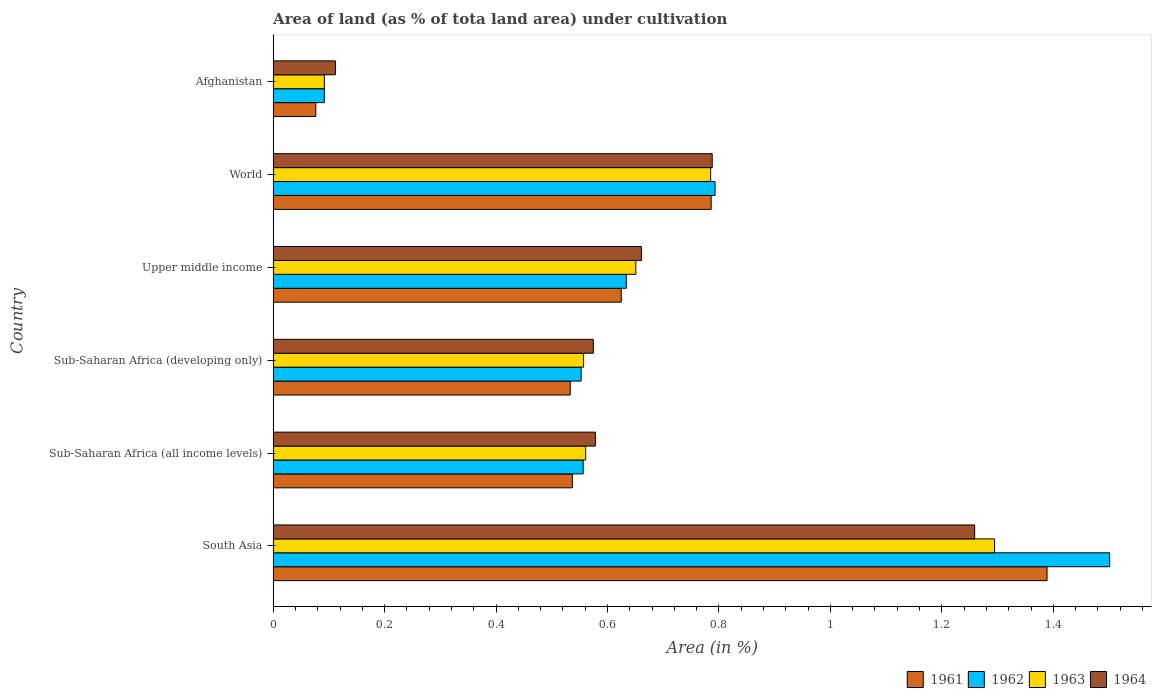How many different coloured bars are there?
Ensure brevity in your answer.  4. How many groups of bars are there?
Offer a terse response. 6. Are the number of bars per tick equal to the number of legend labels?
Your answer should be compact. Yes. Are the number of bars on each tick of the Y-axis equal?
Ensure brevity in your answer.  Yes. What is the label of the 5th group of bars from the top?
Make the answer very short. Sub-Saharan Africa (all income levels). What is the percentage of land under cultivation in 1964 in South Asia?
Provide a succinct answer. 1.26. Across all countries, what is the maximum percentage of land under cultivation in 1962?
Your answer should be very brief. 1.5. Across all countries, what is the minimum percentage of land under cultivation in 1962?
Give a very brief answer. 0.09. In which country was the percentage of land under cultivation in 1964 maximum?
Provide a short and direct response. South Asia. In which country was the percentage of land under cultivation in 1963 minimum?
Your answer should be very brief. Afghanistan. What is the total percentage of land under cultivation in 1962 in the graph?
Make the answer very short. 4.13. What is the difference between the percentage of land under cultivation in 1962 in Upper middle income and that in World?
Provide a short and direct response. -0.16. What is the difference between the percentage of land under cultivation in 1961 in Sub-Saharan Africa (all income levels) and the percentage of land under cultivation in 1964 in Afghanistan?
Provide a short and direct response. 0.43. What is the average percentage of land under cultivation in 1962 per country?
Offer a very short reply. 0.69. What is the difference between the percentage of land under cultivation in 1963 and percentage of land under cultivation in 1961 in Sub-Saharan Africa (all income levels)?
Offer a very short reply. 0.02. What is the ratio of the percentage of land under cultivation in 1964 in Afghanistan to that in Upper middle income?
Make the answer very short. 0.17. Is the difference between the percentage of land under cultivation in 1963 in Upper middle income and World greater than the difference between the percentage of land under cultivation in 1961 in Upper middle income and World?
Your answer should be very brief. Yes. What is the difference between the highest and the second highest percentage of land under cultivation in 1964?
Ensure brevity in your answer.  0.47. What is the difference between the highest and the lowest percentage of land under cultivation in 1963?
Offer a very short reply. 1.2. Is it the case that in every country, the sum of the percentage of land under cultivation in 1963 and percentage of land under cultivation in 1964 is greater than the sum of percentage of land under cultivation in 1961 and percentage of land under cultivation in 1962?
Provide a short and direct response. No. What does the 4th bar from the top in Upper middle income represents?
Your response must be concise. 1961. What does the 3rd bar from the bottom in Sub-Saharan Africa (all income levels) represents?
Your response must be concise. 1963. Is it the case that in every country, the sum of the percentage of land under cultivation in 1962 and percentage of land under cultivation in 1964 is greater than the percentage of land under cultivation in 1961?
Your answer should be compact. Yes. Are all the bars in the graph horizontal?
Make the answer very short. Yes. Does the graph contain grids?
Provide a short and direct response. No. Where does the legend appear in the graph?
Ensure brevity in your answer.  Bottom right. How are the legend labels stacked?
Give a very brief answer. Horizontal. What is the title of the graph?
Your answer should be very brief. Area of land (as % of tota land area) under cultivation. Does "1991" appear as one of the legend labels in the graph?
Ensure brevity in your answer.  No. What is the label or title of the X-axis?
Your answer should be very brief. Area (in %). What is the Area (in %) in 1961 in South Asia?
Offer a very short reply. 1.39. What is the Area (in %) in 1962 in South Asia?
Your response must be concise. 1.5. What is the Area (in %) of 1963 in South Asia?
Give a very brief answer. 1.29. What is the Area (in %) of 1964 in South Asia?
Offer a terse response. 1.26. What is the Area (in %) of 1961 in Sub-Saharan Africa (all income levels)?
Provide a short and direct response. 0.54. What is the Area (in %) of 1962 in Sub-Saharan Africa (all income levels)?
Give a very brief answer. 0.56. What is the Area (in %) in 1963 in Sub-Saharan Africa (all income levels)?
Offer a terse response. 0.56. What is the Area (in %) in 1964 in Sub-Saharan Africa (all income levels)?
Give a very brief answer. 0.58. What is the Area (in %) in 1961 in Sub-Saharan Africa (developing only)?
Provide a succinct answer. 0.53. What is the Area (in %) of 1962 in Sub-Saharan Africa (developing only)?
Provide a short and direct response. 0.55. What is the Area (in %) of 1963 in Sub-Saharan Africa (developing only)?
Provide a succinct answer. 0.56. What is the Area (in %) in 1964 in Sub-Saharan Africa (developing only)?
Provide a succinct answer. 0.57. What is the Area (in %) of 1961 in Upper middle income?
Give a very brief answer. 0.62. What is the Area (in %) in 1962 in Upper middle income?
Your answer should be compact. 0.63. What is the Area (in %) of 1963 in Upper middle income?
Provide a short and direct response. 0.65. What is the Area (in %) in 1964 in Upper middle income?
Give a very brief answer. 0.66. What is the Area (in %) in 1961 in World?
Provide a succinct answer. 0.79. What is the Area (in %) in 1962 in World?
Your answer should be very brief. 0.79. What is the Area (in %) in 1963 in World?
Offer a terse response. 0.79. What is the Area (in %) in 1964 in World?
Your answer should be very brief. 0.79. What is the Area (in %) of 1961 in Afghanistan?
Give a very brief answer. 0.08. What is the Area (in %) of 1962 in Afghanistan?
Ensure brevity in your answer.  0.09. What is the Area (in %) in 1963 in Afghanistan?
Provide a short and direct response. 0.09. What is the Area (in %) of 1964 in Afghanistan?
Your answer should be compact. 0.11. Across all countries, what is the maximum Area (in %) in 1961?
Your response must be concise. 1.39. Across all countries, what is the maximum Area (in %) in 1962?
Provide a short and direct response. 1.5. Across all countries, what is the maximum Area (in %) of 1963?
Your response must be concise. 1.29. Across all countries, what is the maximum Area (in %) of 1964?
Ensure brevity in your answer.  1.26. Across all countries, what is the minimum Area (in %) in 1961?
Make the answer very short. 0.08. Across all countries, what is the minimum Area (in %) in 1962?
Your answer should be very brief. 0.09. Across all countries, what is the minimum Area (in %) of 1963?
Make the answer very short. 0.09. Across all countries, what is the minimum Area (in %) in 1964?
Keep it short and to the point. 0.11. What is the total Area (in %) of 1961 in the graph?
Provide a succinct answer. 3.95. What is the total Area (in %) of 1962 in the graph?
Provide a short and direct response. 4.13. What is the total Area (in %) of 1963 in the graph?
Provide a short and direct response. 3.94. What is the total Area (in %) of 1964 in the graph?
Provide a short and direct response. 3.97. What is the difference between the Area (in %) of 1961 in South Asia and that in Sub-Saharan Africa (all income levels)?
Make the answer very short. 0.85. What is the difference between the Area (in %) of 1962 in South Asia and that in Sub-Saharan Africa (all income levels)?
Offer a terse response. 0.94. What is the difference between the Area (in %) of 1963 in South Asia and that in Sub-Saharan Africa (all income levels)?
Provide a short and direct response. 0.73. What is the difference between the Area (in %) of 1964 in South Asia and that in Sub-Saharan Africa (all income levels)?
Provide a short and direct response. 0.68. What is the difference between the Area (in %) of 1961 in South Asia and that in Sub-Saharan Africa (developing only)?
Your answer should be compact. 0.86. What is the difference between the Area (in %) of 1962 in South Asia and that in Sub-Saharan Africa (developing only)?
Make the answer very short. 0.95. What is the difference between the Area (in %) of 1963 in South Asia and that in Sub-Saharan Africa (developing only)?
Give a very brief answer. 0.74. What is the difference between the Area (in %) in 1964 in South Asia and that in Sub-Saharan Africa (developing only)?
Your response must be concise. 0.68. What is the difference between the Area (in %) in 1961 in South Asia and that in Upper middle income?
Your answer should be very brief. 0.76. What is the difference between the Area (in %) in 1962 in South Asia and that in Upper middle income?
Your answer should be compact. 0.87. What is the difference between the Area (in %) in 1963 in South Asia and that in Upper middle income?
Offer a very short reply. 0.64. What is the difference between the Area (in %) of 1964 in South Asia and that in Upper middle income?
Offer a terse response. 0.6. What is the difference between the Area (in %) in 1961 in South Asia and that in World?
Provide a short and direct response. 0.6. What is the difference between the Area (in %) of 1962 in South Asia and that in World?
Your answer should be compact. 0.71. What is the difference between the Area (in %) in 1963 in South Asia and that in World?
Provide a short and direct response. 0.51. What is the difference between the Area (in %) in 1964 in South Asia and that in World?
Ensure brevity in your answer.  0.47. What is the difference between the Area (in %) of 1961 in South Asia and that in Afghanistan?
Keep it short and to the point. 1.31. What is the difference between the Area (in %) in 1962 in South Asia and that in Afghanistan?
Make the answer very short. 1.41. What is the difference between the Area (in %) in 1963 in South Asia and that in Afghanistan?
Provide a succinct answer. 1.2. What is the difference between the Area (in %) in 1964 in South Asia and that in Afghanistan?
Provide a short and direct response. 1.15. What is the difference between the Area (in %) of 1961 in Sub-Saharan Africa (all income levels) and that in Sub-Saharan Africa (developing only)?
Ensure brevity in your answer.  0. What is the difference between the Area (in %) of 1962 in Sub-Saharan Africa (all income levels) and that in Sub-Saharan Africa (developing only)?
Give a very brief answer. 0. What is the difference between the Area (in %) in 1963 in Sub-Saharan Africa (all income levels) and that in Sub-Saharan Africa (developing only)?
Give a very brief answer. 0. What is the difference between the Area (in %) in 1964 in Sub-Saharan Africa (all income levels) and that in Sub-Saharan Africa (developing only)?
Provide a succinct answer. 0. What is the difference between the Area (in %) in 1961 in Sub-Saharan Africa (all income levels) and that in Upper middle income?
Offer a very short reply. -0.09. What is the difference between the Area (in %) in 1962 in Sub-Saharan Africa (all income levels) and that in Upper middle income?
Offer a terse response. -0.08. What is the difference between the Area (in %) of 1963 in Sub-Saharan Africa (all income levels) and that in Upper middle income?
Offer a very short reply. -0.09. What is the difference between the Area (in %) in 1964 in Sub-Saharan Africa (all income levels) and that in Upper middle income?
Keep it short and to the point. -0.08. What is the difference between the Area (in %) of 1961 in Sub-Saharan Africa (all income levels) and that in World?
Offer a very short reply. -0.25. What is the difference between the Area (in %) in 1962 in Sub-Saharan Africa (all income levels) and that in World?
Give a very brief answer. -0.24. What is the difference between the Area (in %) of 1963 in Sub-Saharan Africa (all income levels) and that in World?
Offer a very short reply. -0.22. What is the difference between the Area (in %) of 1964 in Sub-Saharan Africa (all income levels) and that in World?
Your response must be concise. -0.21. What is the difference between the Area (in %) in 1961 in Sub-Saharan Africa (all income levels) and that in Afghanistan?
Provide a short and direct response. 0.46. What is the difference between the Area (in %) in 1962 in Sub-Saharan Africa (all income levels) and that in Afghanistan?
Your answer should be compact. 0.46. What is the difference between the Area (in %) of 1963 in Sub-Saharan Africa (all income levels) and that in Afghanistan?
Your response must be concise. 0.47. What is the difference between the Area (in %) of 1964 in Sub-Saharan Africa (all income levels) and that in Afghanistan?
Your answer should be very brief. 0.47. What is the difference between the Area (in %) in 1961 in Sub-Saharan Africa (developing only) and that in Upper middle income?
Your answer should be compact. -0.09. What is the difference between the Area (in %) of 1962 in Sub-Saharan Africa (developing only) and that in Upper middle income?
Provide a succinct answer. -0.08. What is the difference between the Area (in %) of 1963 in Sub-Saharan Africa (developing only) and that in Upper middle income?
Your answer should be very brief. -0.09. What is the difference between the Area (in %) of 1964 in Sub-Saharan Africa (developing only) and that in Upper middle income?
Keep it short and to the point. -0.09. What is the difference between the Area (in %) of 1961 in Sub-Saharan Africa (developing only) and that in World?
Provide a short and direct response. -0.25. What is the difference between the Area (in %) in 1962 in Sub-Saharan Africa (developing only) and that in World?
Offer a very short reply. -0.24. What is the difference between the Area (in %) of 1963 in Sub-Saharan Africa (developing only) and that in World?
Keep it short and to the point. -0.23. What is the difference between the Area (in %) of 1964 in Sub-Saharan Africa (developing only) and that in World?
Make the answer very short. -0.21. What is the difference between the Area (in %) of 1961 in Sub-Saharan Africa (developing only) and that in Afghanistan?
Your answer should be compact. 0.46. What is the difference between the Area (in %) of 1962 in Sub-Saharan Africa (developing only) and that in Afghanistan?
Your answer should be very brief. 0.46. What is the difference between the Area (in %) in 1963 in Sub-Saharan Africa (developing only) and that in Afghanistan?
Keep it short and to the point. 0.47. What is the difference between the Area (in %) of 1964 in Sub-Saharan Africa (developing only) and that in Afghanistan?
Your answer should be compact. 0.46. What is the difference between the Area (in %) of 1961 in Upper middle income and that in World?
Your answer should be compact. -0.16. What is the difference between the Area (in %) in 1962 in Upper middle income and that in World?
Give a very brief answer. -0.16. What is the difference between the Area (in %) in 1963 in Upper middle income and that in World?
Make the answer very short. -0.13. What is the difference between the Area (in %) of 1964 in Upper middle income and that in World?
Keep it short and to the point. -0.13. What is the difference between the Area (in %) of 1961 in Upper middle income and that in Afghanistan?
Ensure brevity in your answer.  0.55. What is the difference between the Area (in %) in 1962 in Upper middle income and that in Afghanistan?
Your answer should be very brief. 0.54. What is the difference between the Area (in %) of 1963 in Upper middle income and that in Afghanistan?
Ensure brevity in your answer.  0.56. What is the difference between the Area (in %) of 1964 in Upper middle income and that in Afghanistan?
Offer a terse response. 0.55. What is the difference between the Area (in %) of 1961 in World and that in Afghanistan?
Offer a terse response. 0.71. What is the difference between the Area (in %) of 1962 in World and that in Afghanistan?
Keep it short and to the point. 0.7. What is the difference between the Area (in %) of 1963 in World and that in Afghanistan?
Provide a succinct answer. 0.69. What is the difference between the Area (in %) of 1964 in World and that in Afghanistan?
Offer a terse response. 0.68. What is the difference between the Area (in %) in 1961 in South Asia and the Area (in %) in 1962 in Sub-Saharan Africa (all income levels)?
Your answer should be compact. 0.83. What is the difference between the Area (in %) in 1961 in South Asia and the Area (in %) in 1963 in Sub-Saharan Africa (all income levels)?
Provide a succinct answer. 0.83. What is the difference between the Area (in %) in 1961 in South Asia and the Area (in %) in 1964 in Sub-Saharan Africa (all income levels)?
Your response must be concise. 0.81. What is the difference between the Area (in %) in 1962 in South Asia and the Area (in %) in 1963 in Sub-Saharan Africa (all income levels)?
Your response must be concise. 0.94. What is the difference between the Area (in %) of 1962 in South Asia and the Area (in %) of 1964 in Sub-Saharan Africa (all income levels)?
Offer a terse response. 0.92. What is the difference between the Area (in %) in 1963 in South Asia and the Area (in %) in 1964 in Sub-Saharan Africa (all income levels)?
Ensure brevity in your answer.  0.72. What is the difference between the Area (in %) of 1961 in South Asia and the Area (in %) of 1962 in Sub-Saharan Africa (developing only)?
Provide a short and direct response. 0.84. What is the difference between the Area (in %) of 1961 in South Asia and the Area (in %) of 1963 in Sub-Saharan Africa (developing only)?
Your answer should be very brief. 0.83. What is the difference between the Area (in %) in 1961 in South Asia and the Area (in %) in 1964 in Sub-Saharan Africa (developing only)?
Offer a very short reply. 0.81. What is the difference between the Area (in %) in 1962 in South Asia and the Area (in %) in 1963 in Sub-Saharan Africa (developing only)?
Your response must be concise. 0.94. What is the difference between the Area (in %) in 1962 in South Asia and the Area (in %) in 1964 in Sub-Saharan Africa (developing only)?
Keep it short and to the point. 0.93. What is the difference between the Area (in %) of 1963 in South Asia and the Area (in %) of 1964 in Sub-Saharan Africa (developing only)?
Your response must be concise. 0.72. What is the difference between the Area (in %) of 1961 in South Asia and the Area (in %) of 1962 in Upper middle income?
Your answer should be very brief. 0.76. What is the difference between the Area (in %) of 1961 in South Asia and the Area (in %) of 1963 in Upper middle income?
Give a very brief answer. 0.74. What is the difference between the Area (in %) in 1961 in South Asia and the Area (in %) in 1964 in Upper middle income?
Provide a short and direct response. 0.73. What is the difference between the Area (in %) of 1962 in South Asia and the Area (in %) of 1963 in Upper middle income?
Keep it short and to the point. 0.85. What is the difference between the Area (in %) in 1962 in South Asia and the Area (in %) in 1964 in Upper middle income?
Your response must be concise. 0.84. What is the difference between the Area (in %) of 1963 in South Asia and the Area (in %) of 1964 in Upper middle income?
Provide a short and direct response. 0.63. What is the difference between the Area (in %) of 1961 in South Asia and the Area (in %) of 1962 in World?
Offer a very short reply. 0.6. What is the difference between the Area (in %) of 1961 in South Asia and the Area (in %) of 1963 in World?
Keep it short and to the point. 0.6. What is the difference between the Area (in %) of 1961 in South Asia and the Area (in %) of 1964 in World?
Ensure brevity in your answer.  0.6. What is the difference between the Area (in %) of 1962 in South Asia and the Area (in %) of 1963 in World?
Provide a succinct answer. 0.72. What is the difference between the Area (in %) in 1962 in South Asia and the Area (in %) in 1964 in World?
Make the answer very short. 0.71. What is the difference between the Area (in %) in 1963 in South Asia and the Area (in %) in 1964 in World?
Ensure brevity in your answer.  0.51. What is the difference between the Area (in %) in 1961 in South Asia and the Area (in %) in 1962 in Afghanistan?
Keep it short and to the point. 1.3. What is the difference between the Area (in %) in 1961 in South Asia and the Area (in %) in 1963 in Afghanistan?
Provide a succinct answer. 1.3. What is the difference between the Area (in %) in 1961 in South Asia and the Area (in %) in 1964 in Afghanistan?
Your answer should be very brief. 1.28. What is the difference between the Area (in %) in 1962 in South Asia and the Area (in %) in 1963 in Afghanistan?
Offer a very short reply. 1.41. What is the difference between the Area (in %) in 1962 in South Asia and the Area (in %) in 1964 in Afghanistan?
Provide a succinct answer. 1.39. What is the difference between the Area (in %) of 1963 in South Asia and the Area (in %) of 1964 in Afghanistan?
Offer a very short reply. 1.18. What is the difference between the Area (in %) of 1961 in Sub-Saharan Africa (all income levels) and the Area (in %) of 1962 in Sub-Saharan Africa (developing only)?
Ensure brevity in your answer.  -0.02. What is the difference between the Area (in %) in 1961 in Sub-Saharan Africa (all income levels) and the Area (in %) in 1963 in Sub-Saharan Africa (developing only)?
Offer a terse response. -0.02. What is the difference between the Area (in %) of 1961 in Sub-Saharan Africa (all income levels) and the Area (in %) of 1964 in Sub-Saharan Africa (developing only)?
Ensure brevity in your answer.  -0.04. What is the difference between the Area (in %) of 1962 in Sub-Saharan Africa (all income levels) and the Area (in %) of 1963 in Sub-Saharan Africa (developing only)?
Your answer should be very brief. -0. What is the difference between the Area (in %) of 1962 in Sub-Saharan Africa (all income levels) and the Area (in %) of 1964 in Sub-Saharan Africa (developing only)?
Provide a short and direct response. -0.02. What is the difference between the Area (in %) of 1963 in Sub-Saharan Africa (all income levels) and the Area (in %) of 1964 in Sub-Saharan Africa (developing only)?
Your answer should be very brief. -0.01. What is the difference between the Area (in %) of 1961 in Sub-Saharan Africa (all income levels) and the Area (in %) of 1962 in Upper middle income?
Offer a very short reply. -0.1. What is the difference between the Area (in %) in 1961 in Sub-Saharan Africa (all income levels) and the Area (in %) in 1963 in Upper middle income?
Provide a succinct answer. -0.11. What is the difference between the Area (in %) of 1961 in Sub-Saharan Africa (all income levels) and the Area (in %) of 1964 in Upper middle income?
Offer a very short reply. -0.12. What is the difference between the Area (in %) of 1962 in Sub-Saharan Africa (all income levels) and the Area (in %) of 1963 in Upper middle income?
Offer a terse response. -0.09. What is the difference between the Area (in %) of 1962 in Sub-Saharan Africa (all income levels) and the Area (in %) of 1964 in Upper middle income?
Your answer should be very brief. -0.1. What is the difference between the Area (in %) in 1963 in Sub-Saharan Africa (all income levels) and the Area (in %) in 1964 in Upper middle income?
Ensure brevity in your answer.  -0.1. What is the difference between the Area (in %) of 1961 in Sub-Saharan Africa (all income levels) and the Area (in %) of 1962 in World?
Your response must be concise. -0.26. What is the difference between the Area (in %) of 1961 in Sub-Saharan Africa (all income levels) and the Area (in %) of 1963 in World?
Ensure brevity in your answer.  -0.25. What is the difference between the Area (in %) in 1961 in Sub-Saharan Africa (all income levels) and the Area (in %) in 1964 in World?
Keep it short and to the point. -0.25. What is the difference between the Area (in %) in 1962 in Sub-Saharan Africa (all income levels) and the Area (in %) in 1963 in World?
Keep it short and to the point. -0.23. What is the difference between the Area (in %) in 1962 in Sub-Saharan Africa (all income levels) and the Area (in %) in 1964 in World?
Your answer should be very brief. -0.23. What is the difference between the Area (in %) in 1963 in Sub-Saharan Africa (all income levels) and the Area (in %) in 1964 in World?
Your answer should be very brief. -0.23. What is the difference between the Area (in %) in 1961 in Sub-Saharan Africa (all income levels) and the Area (in %) in 1962 in Afghanistan?
Ensure brevity in your answer.  0.45. What is the difference between the Area (in %) of 1961 in Sub-Saharan Africa (all income levels) and the Area (in %) of 1963 in Afghanistan?
Offer a very short reply. 0.45. What is the difference between the Area (in %) of 1961 in Sub-Saharan Africa (all income levels) and the Area (in %) of 1964 in Afghanistan?
Your response must be concise. 0.43. What is the difference between the Area (in %) in 1962 in Sub-Saharan Africa (all income levels) and the Area (in %) in 1963 in Afghanistan?
Provide a short and direct response. 0.46. What is the difference between the Area (in %) of 1962 in Sub-Saharan Africa (all income levels) and the Area (in %) of 1964 in Afghanistan?
Offer a terse response. 0.44. What is the difference between the Area (in %) of 1963 in Sub-Saharan Africa (all income levels) and the Area (in %) of 1964 in Afghanistan?
Offer a terse response. 0.45. What is the difference between the Area (in %) in 1961 in Sub-Saharan Africa (developing only) and the Area (in %) in 1962 in Upper middle income?
Keep it short and to the point. -0.1. What is the difference between the Area (in %) in 1961 in Sub-Saharan Africa (developing only) and the Area (in %) in 1963 in Upper middle income?
Offer a terse response. -0.12. What is the difference between the Area (in %) of 1961 in Sub-Saharan Africa (developing only) and the Area (in %) of 1964 in Upper middle income?
Your answer should be very brief. -0.13. What is the difference between the Area (in %) of 1962 in Sub-Saharan Africa (developing only) and the Area (in %) of 1963 in Upper middle income?
Your answer should be compact. -0.1. What is the difference between the Area (in %) in 1962 in Sub-Saharan Africa (developing only) and the Area (in %) in 1964 in Upper middle income?
Offer a terse response. -0.11. What is the difference between the Area (in %) of 1963 in Sub-Saharan Africa (developing only) and the Area (in %) of 1964 in Upper middle income?
Give a very brief answer. -0.1. What is the difference between the Area (in %) in 1961 in Sub-Saharan Africa (developing only) and the Area (in %) in 1962 in World?
Provide a short and direct response. -0.26. What is the difference between the Area (in %) of 1961 in Sub-Saharan Africa (developing only) and the Area (in %) of 1963 in World?
Offer a terse response. -0.25. What is the difference between the Area (in %) of 1961 in Sub-Saharan Africa (developing only) and the Area (in %) of 1964 in World?
Ensure brevity in your answer.  -0.25. What is the difference between the Area (in %) in 1962 in Sub-Saharan Africa (developing only) and the Area (in %) in 1963 in World?
Ensure brevity in your answer.  -0.23. What is the difference between the Area (in %) of 1962 in Sub-Saharan Africa (developing only) and the Area (in %) of 1964 in World?
Make the answer very short. -0.24. What is the difference between the Area (in %) of 1963 in Sub-Saharan Africa (developing only) and the Area (in %) of 1964 in World?
Give a very brief answer. -0.23. What is the difference between the Area (in %) in 1961 in Sub-Saharan Africa (developing only) and the Area (in %) in 1962 in Afghanistan?
Keep it short and to the point. 0.44. What is the difference between the Area (in %) of 1961 in Sub-Saharan Africa (developing only) and the Area (in %) of 1963 in Afghanistan?
Your answer should be compact. 0.44. What is the difference between the Area (in %) in 1961 in Sub-Saharan Africa (developing only) and the Area (in %) in 1964 in Afghanistan?
Provide a succinct answer. 0.42. What is the difference between the Area (in %) in 1962 in Sub-Saharan Africa (developing only) and the Area (in %) in 1963 in Afghanistan?
Ensure brevity in your answer.  0.46. What is the difference between the Area (in %) of 1962 in Sub-Saharan Africa (developing only) and the Area (in %) of 1964 in Afghanistan?
Provide a short and direct response. 0.44. What is the difference between the Area (in %) of 1963 in Sub-Saharan Africa (developing only) and the Area (in %) of 1964 in Afghanistan?
Offer a very short reply. 0.45. What is the difference between the Area (in %) in 1961 in Upper middle income and the Area (in %) in 1962 in World?
Your answer should be very brief. -0.17. What is the difference between the Area (in %) of 1961 in Upper middle income and the Area (in %) of 1963 in World?
Offer a very short reply. -0.16. What is the difference between the Area (in %) in 1961 in Upper middle income and the Area (in %) in 1964 in World?
Make the answer very short. -0.16. What is the difference between the Area (in %) of 1962 in Upper middle income and the Area (in %) of 1963 in World?
Offer a very short reply. -0.15. What is the difference between the Area (in %) of 1962 in Upper middle income and the Area (in %) of 1964 in World?
Ensure brevity in your answer.  -0.15. What is the difference between the Area (in %) in 1963 in Upper middle income and the Area (in %) in 1964 in World?
Provide a short and direct response. -0.14. What is the difference between the Area (in %) in 1961 in Upper middle income and the Area (in %) in 1962 in Afghanistan?
Your answer should be compact. 0.53. What is the difference between the Area (in %) of 1961 in Upper middle income and the Area (in %) of 1963 in Afghanistan?
Offer a terse response. 0.53. What is the difference between the Area (in %) in 1961 in Upper middle income and the Area (in %) in 1964 in Afghanistan?
Ensure brevity in your answer.  0.51. What is the difference between the Area (in %) of 1962 in Upper middle income and the Area (in %) of 1963 in Afghanistan?
Ensure brevity in your answer.  0.54. What is the difference between the Area (in %) of 1962 in Upper middle income and the Area (in %) of 1964 in Afghanistan?
Your answer should be compact. 0.52. What is the difference between the Area (in %) in 1963 in Upper middle income and the Area (in %) in 1964 in Afghanistan?
Your answer should be very brief. 0.54. What is the difference between the Area (in %) in 1961 in World and the Area (in %) in 1962 in Afghanistan?
Make the answer very short. 0.69. What is the difference between the Area (in %) in 1961 in World and the Area (in %) in 1963 in Afghanistan?
Keep it short and to the point. 0.69. What is the difference between the Area (in %) of 1961 in World and the Area (in %) of 1964 in Afghanistan?
Provide a short and direct response. 0.67. What is the difference between the Area (in %) of 1962 in World and the Area (in %) of 1963 in Afghanistan?
Offer a very short reply. 0.7. What is the difference between the Area (in %) in 1962 in World and the Area (in %) in 1964 in Afghanistan?
Keep it short and to the point. 0.68. What is the difference between the Area (in %) of 1963 in World and the Area (in %) of 1964 in Afghanistan?
Your answer should be very brief. 0.67. What is the average Area (in %) in 1961 per country?
Your answer should be compact. 0.66. What is the average Area (in %) in 1962 per country?
Give a very brief answer. 0.69. What is the average Area (in %) in 1963 per country?
Keep it short and to the point. 0.66. What is the average Area (in %) of 1964 per country?
Give a very brief answer. 0.66. What is the difference between the Area (in %) of 1961 and Area (in %) of 1962 in South Asia?
Give a very brief answer. -0.11. What is the difference between the Area (in %) in 1961 and Area (in %) in 1963 in South Asia?
Give a very brief answer. 0.09. What is the difference between the Area (in %) of 1961 and Area (in %) of 1964 in South Asia?
Offer a terse response. 0.13. What is the difference between the Area (in %) of 1962 and Area (in %) of 1963 in South Asia?
Provide a succinct answer. 0.21. What is the difference between the Area (in %) of 1962 and Area (in %) of 1964 in South Asia?
Ensure brevity in your answer.  0.24. What is the difference between the Area (in %) in 1963 and Area (in %) in 1964 in South Asia?
Offer a terse response. 0.04. What is the difference between the Area (in %) in 1961 and Area (in %) in 1962 in Sub-Saharan Africa (all income levels)?
Offer a terse response. -0.02. What is the difference between the Area (in %) of 1961 and Area (in %) of 1963 in Sub-Saharan Africa (all income levels)?
Your answer should be very brief. -0.02. What is the difference between the Area (in %) in 1961 and Area (in %) in 1964 in Sub-Saharan Africa (all income levels)?
Provide a succinct answer. -0.04. What is the difference between the Area (in %) in 1962 and Area (in %) in 1963 in Sub-Saharan Africa (all income levels)?
Ensure brevity in your answer.  -0. What is the difference between the Area (in %) in 1962 and Area (in %) in 1964 in Sub-Saharan Africa (all income levels)?
Keep it short and to the point. -0.02. What is the difference between the Area (in %) of 1963 and Area (in %) of 1964 in Sub-Saharan Africa (all income levels)?
Keep it short and to the point. -0.02. What is the difference between the Area (in %) of 1961 and Area (in %) of 1962 in Sub-Saharan Africa (developing only)?
Keep it short and to the point. -0.02. What is the difference between the Area (in %) in 1961 and Area (in %) in 1963 in Sub-Saharan Africa (developing only)?
Offer a terse response. -0.02. What is the difference between the Area (in %) in 1961 and Area (in %) in 1964 in Sub-Saharan Africa (developing only)?
Make the answer very short. -0.04. What is the difference between the Area (in %) of 1962 and Area (in %) of 1963 in Sub-Saharan Africa (developing only)?
Offer a terse response. -0. What is the difference between the Area (in %) in 1962 and Area (in %) in 1964 in Sub-Saharan Africa (developing only)?
Your response must be concise. -0.02. What is the difference between the Area (in %) of 1963 and Area (in %) of 1964 in Sub-Saharan Africa (developing only)?
Provide a short and direct response. -0.02. What is the difference between the Area (in %) in 1961 and Area (in %) in 1962 in Upper middle income?
Your answer should be compact. -0.01. What is the difference between the Area (in %) in 1961 and Area (in %) in 1963 in Upper middle income?
Offer a very short reply. -0.03. What is the difference between the Area (in %) of 1961 and Area (in %) of 1964 in Upper middle income?
Your answer should be very brief. -0.04. What is the difference between the Area (in %) of 1962 and Area (in %) of 1963 in Upper middle income?
Offer a terse response. -0.02. What is the difference between the Area (in %) of 1962 and Area (in %) of 1964 in Upper middle income?
Offer a terse response. -0.03. What is the difference between the Area (in %) in 1963 and Area (in %) in 1964 in Upper middle income?
Make the answer very short. -0.01. What is the difference between the Area (in %) in 1961 and Area (in %) in 1962 in World?
Keep it short and to the point. -0.01. What is the difference between the Area (in %) of 1961 and Area (in %) of 1963 in World?
Keep it short and to the point. 0. What is the difference between the Area (in %) of 1961 and Area (in %) of 1964 in World?
Keep it short and to the point. -0. What is the difference between the Area (in %) of 1962 and Area (in %) of 1963 in World?
Your response must be concise. 0.01. What is the difference between the Area (in %) of 1962 and Area (in %) of 1964 in World?
Offer a terse response. 0.01. What is the difference between the Area (in %) of 1963 and Area (in %) of 1964 in World?
Give a very brief answer. -0. What is the difference between the Area (in %) of 1961 and Area (in %) of 1962 in Afghanistan?
Make the answer very short. -0.02. What is the difference between the Area (in %) in 1961 and Area (in %) in 1963 in Afghanistan?
Make the answer very short. -0.02. What is the difference between the Area (in %) in 1961 and Area (in %) in 1964 in Afghanistan?
Ensure brevity in your answer.  -0.04. What is the difference between the Area (in %) in 1962 and Area (in %) in 1964 in Afghanistan?
Keep it short and to the point. -0.02. What is the difference between the Area (in %) of 1963 and Area (in %) of 1964 in Afghanistan?
Make the answer very short. -0.02. What is the ratio of the Area (in %) in 1961 in South Asia to that in Sub-Saharan Africa (all income levels)?
Provide a succinct answer. 2.59. What is the ratio of the Area (in %) in 1962 in South Asia to that in Sub-Saharan Africa (all income levels)?
Your response must be concise. 2.7. What is the ratio of the Area (in %) of 1963 in South Asia to that in Sub-Saharan Africa (all income levels)?
Your answer should be compact. 2.31. What is the ratio of the Area (in %) in 1964 in South Asia to that in Sub-Saharan Africa (all income levels)?
Your response must be concise. 2.18. What is the ratio of the Area (in %) of 1961 in South Asia to that in Sub-Saharan Africa (developing only)?
Your answer should be very brief. 2.6. What is the ratio of the Area (in %) in 1962 in South Asia to that in Sub-Saharan Africa (developing only)?
Offer a very short reply. 2.72. What is the ratio of the Area (in %) in 1963 in South Asia to that in Sub-Saharan Africa (developing only)?
Provide a succinct answer. 2.32. What is the ratio of the Area (in %) in 1964 in South Asia to that in Sub-Saharan Africa (developing only)?
Provide a succinct answer. 2.19. What is the ratio of the Area (in %) of 1961 in South Asia to that in Upper middle income?
Your answer should be very brief. 2.22. What is the ratio of the Area (in %) of 1962 in South Asia to that in Upper middle income?
Provide a short and direct response. 2.37. What is the ratio of the Area (in %) in 1963 in South Asia to that in Upper middle income?
Offer a very short reply. 1.99. What is the ratio of the Area (in %) in 1964 in South Asia to that in Upper middle income?
Provide a short and direct response. 1.9. What is the ratio of the Area (in %) of 1961 in South Asia to that in World?
Your answer should be compact. 1.77. What is the ratio of the Area (in %) in 1962 in South Asia to that in World?
Give a very brief answer. 1.89. What is the ratio of the Area (in %) of 1963 in South Asia to that in World?
Give a very brief answer. 1.65. What is the ratio of the Area (in %) in 1964 in South Asia to that in World?
Provide a succinct answer. 1.6. What is the ratio of the Area (in %) of 1961 in South Asia to that in Afghanistan?
Make the answer very short. 18.13. What is the ratio of the Area (in %) of 1962 in South Asia to that in Afghanistan?
Offer a very short reply. 16.33. What is the ratio of the Area (in %) of 1963 in South Asia to that in Afghanistan?
Provide a short and direct response. 14.09. What is the ratio of the Area (in %) in 1964 in South Asia to that in Afghanistan?
Offer a very short reply. 11.26. What is the ratio of the Area (in %) in 1961 in Sub-Saharan Africa (all income levels) to that in Sub-Saharan Africa (developing only)?
Your answer should be compact. 1.01. What is the ratio of the Area (in %) of 1962 in Sub-Saharan Africa (all income levels) to that in Sub-Saharan Africa (developing only)?
Provide a succinct answer. 1.01. What is the ratio of the Area (in %) in 1961 in Sub-Saharan Africa (all income levels) to that in Upper middle income?
Provide a short and direct response. 0.86. What is the ratio of the Area (in %) in 1962 in Sub-Saharan Africa (all income levels) to that in Upper middle income?
Offer a very short reply. 0.88. What is the ratio of the Area (in %) of 1963 in Sub-Saharan Africa (all income levels) to that in Upper middle income?
Provide a short and direct response. 0.86. What is the ratio of the Area (in %) of 1964 in Sub-Saharan Africa (all income levels) to that in Upper middle income?
Keep it short and to the point. 0.87. What is the ratio of the Area (in %) in 1961 in Sub-Saharan Africa (all income levels) to that in World?
Offer a terse response. 0.68. What is the ratio of the Area (in %) of 1962 in Sub-Saharan Africa (all income levels) to that in World?
Your answer should be compact. 0.7. What is the ratio of the Area (in %) of 1963 in Sub-Saharan Africa (all income levels) to that in World?
Make the answer very short. 0.71. What is the ratio of the Area (in %) in 1964 in Sub-Saharan Africa (all income levels) to that in World?
Your answer should be compact. 0.73. What is the ratio of the Area (in %) of 1961 in Sub-Saharan Africa (all income levels) to that in Afghanistan?
Keep it short and to the point. 7.01. What is the ratio of the Area (in %) in 1962 in Sub-Saharan Africa (all income levels) to that in Afghanistan?
Your answer should be compact. 6.05. What is the ratio of the Area (in %) in 1963 in Sub-Saharan Africa (all income levels) to that in Afghanistan?
Offer a terse response. 6.1. What is the ratio of the Area (in %) in 1964 in Sub-Saharan Africa (all income levels) to that in Afghanistan?
Your response must be concise. 5.17. What is the ratio of the Area (in %) of 1961 in Sub-Saharan Africa (developing only) to that in Upper middle income?
Make the answer very short. 0.85. What is the ratio of the Area (in %) in 1962 in Sub-Saharan Africa (developing only) to that in Upper middle income?
Give a very brief answer. 0.87. What is the ratio of the Area (in %) of 1963 in Sub-Saharan Africa (developing only) to that in Upper middle income?
Keep it short and to the point. 0.86. What is the ratio of the Area (in %) of 1964 in Sub-Saharan Africa (developing only) to that in Upper middle income?
Provide a short and direct response. 0.87. What is the ratio of the Area (in %) in 1961 in Sub-Saharan Africa (developing only) to that in World?
Offer a terse response. 0.68. What is the ratio of the Area (in %) of 1962 in Sub-Saharan Africa (developing only) to that in World?
Your answer should be compact. 0.7. What is the ratio of the Area (in %) in 1963 in Sub-Saharan Africa (developing only) to that in World?
Your answer should be compact. 0.71. What is the ratio of the Area (in %) of 1964 in Sub-Saharan Africa (developing only) to that in World?
Your answer should be compact. 0.73. What is the ratio of the Area (in %) of 1961 in Sub-Saharan Africa (developing only) to that in Afghanistan?
Provide a succinct answer. 6.96. What is the ratio of the Area (in %) in 1962 in Sub-Saharan Africa (developing only) to that in Afghanistan?
Provide a succinct answer. 6.01. What is the ratio of the Area (in %) of 1963 in Sub-Saharan Africa (developing only) to that in Afghanistan?
Offer a terse response. 6.06. What is the ratio of the Area (in %) in 1964 in Sub-Saharan Africa (developing only) to that in Afghanistan?
Provide a succinct answer. 5.14. What is the ratio of the Area (in %) in 1961 in Upper middle income to that in World?
Offer a very short reply. 0.79. What is the ratio of the Area (in %) of 1962 in Upper middle income to that in World?
Provide a short and direct response. 0.8. What is the ratio of the Area (in %) of 1963 in Upper middle income to that in World?
Your answer should be compact. 0.83. What is the ratio of the Area (in %) in 1964 in Upper middle income to that in World?
Keep it short and to the point. 0.84. What is the ratio of the Area (in %) of 1961 in Upper middle income to that in Afghanistan?
Offer a terse response. 8.16. What is the ratio of the Area (in %) of 1962 in Upper middle income to that in Afghanistan?
Keep it short and to the point. 6.9. What is the ratio of the Area (in %) of 1963 in Upper middle income to that in Afghanistan?
Your response must be concise. 7.08. What is the ratio of the Area (in %) in 1964 in Upper middle income to that in Afghanistan?
Offer a terse response. 5.91. What is the ratio of the Area (in %) of 1961 in World to that in Afghanistan?
Offer a terse response. 10.26. What is the ratio of the Area (in %) of 1962 in World to that in Afghanistan?
Your response must be concise. 8.63. What is the ratio of the Area (in %) in 1963 in World to that in Afghanistan?
Your answer should be compact. 8.54. What is the ratio of the Area (in %) of 1964 in World to that in Afghanistan?
Give a very brief answer. 7.05. What is the difference between the highest and the second highest Area (in %) of 1961?
Make the answer very short. 0.6. What is the difference between the highest and the second highest Area (in %) in 1962?
Keep it short and to the point. 0.71. What is the difference between the highest and the second highest Area (in %) of 1963?
Ensure brevity in your answer.  0.51. What is the difference between the highest and the second highest Area (in %) of 1964?
Ensure brevity in your answer.  0.47. What is the difference between the highest and the lowest Area (in %) of 1961?
Your answer should be very brief. 1.31. What is the difference between the highest and the lowest Area (in %) of 1962?
Ensure brevity in your answer.  1.41. What is the difference between the highest and the lowest Area (in %) in 1963?
Provide a succinct answer. 1.2. What is the difference between the highest and the lowest Area (in %) of 1964?
Your answer should be very brief. 1.15. 